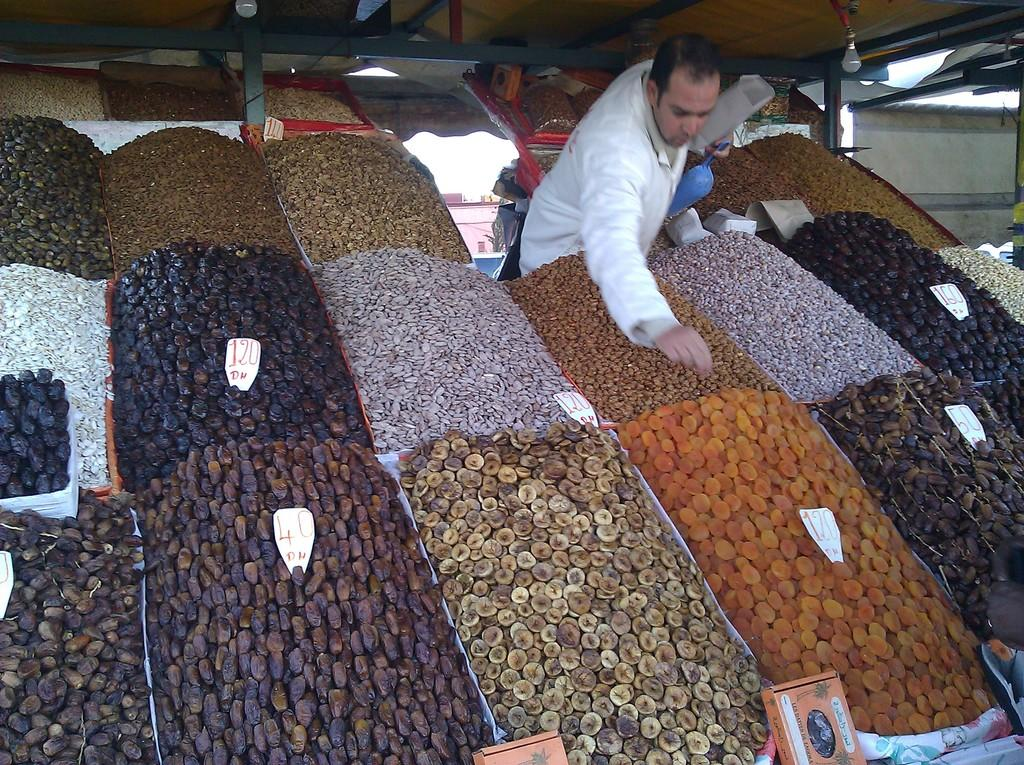What types of food items can be seen in the image? There are different food items in the image. Can you describe the person in the image? There is a man standing in the image. What is the source of illumination in the image? There is light in the image. What type of humor does the man's partner display in the image? There is no partner present in the image, and therefore no humor can be attributed to them. 